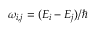<formula> <loc_0><loc_0><loc_500><loc_500>\omega _ { i , j } = ( E _ { i } - E _ { j } ) / \hbar</formula> 